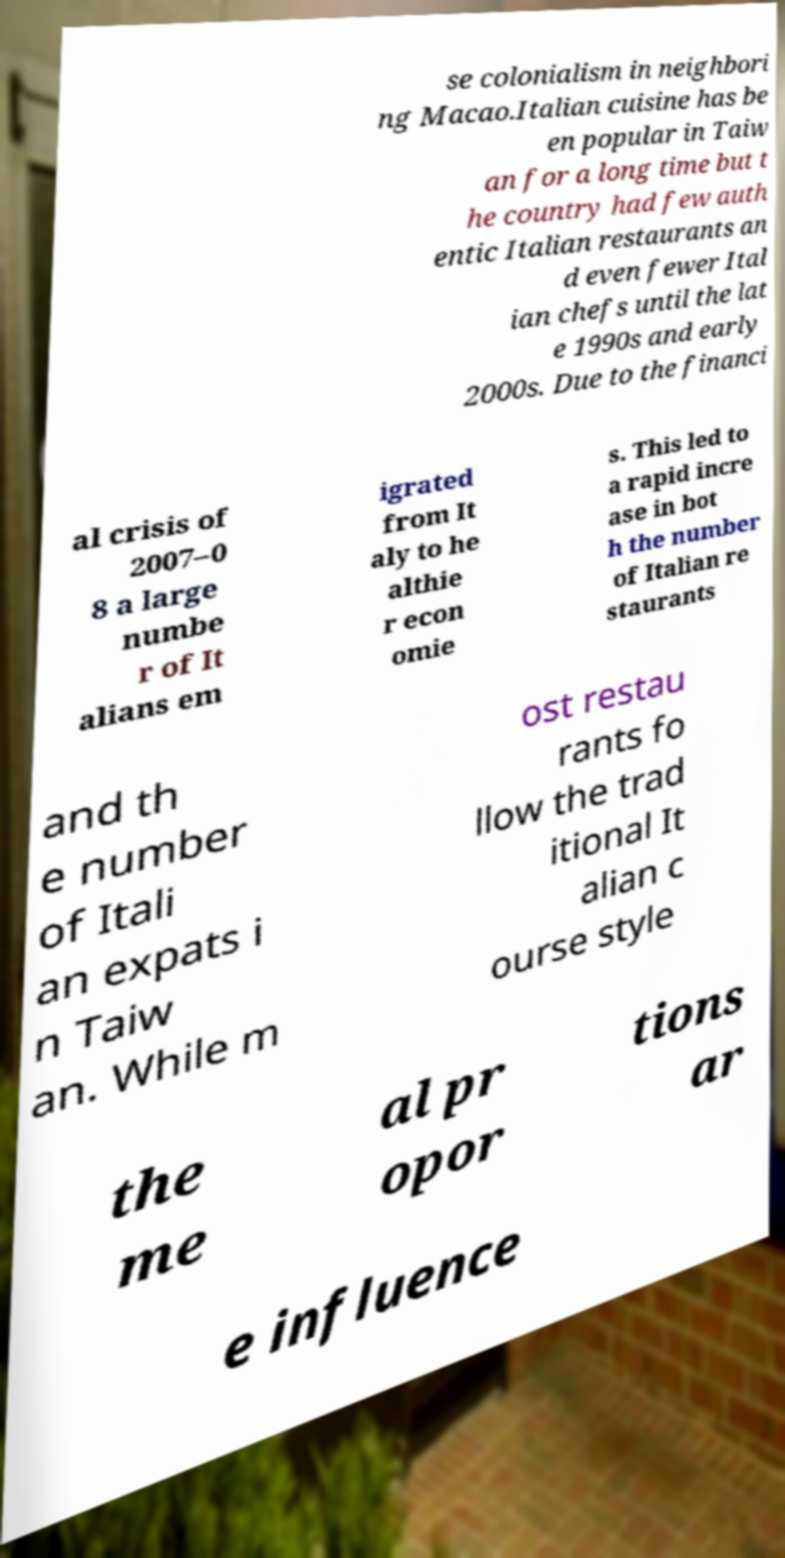Could you assist in decoding the text presented in this image and type it out clearly? se colonialism in neighbori ng Macao.Italian cuisine has be en popular in Taiw an for a long time but t he country had few auth entic Italian restaurants an d even fewer Ital ian chefs until the lat e 1990s and early 2000s. Due to the financi al crisis of 2007–0 8 a large numbe r of It alians em igrated from It aly to he althie r econ omie s. This led to a rapid incre ase in bot h the number of Italian re staurants and th e number of Itali an expats i n Taiw an. While m ost restau rants fo llow the trad itional It alian c ourse style the me al pr opor tions ar e influence 